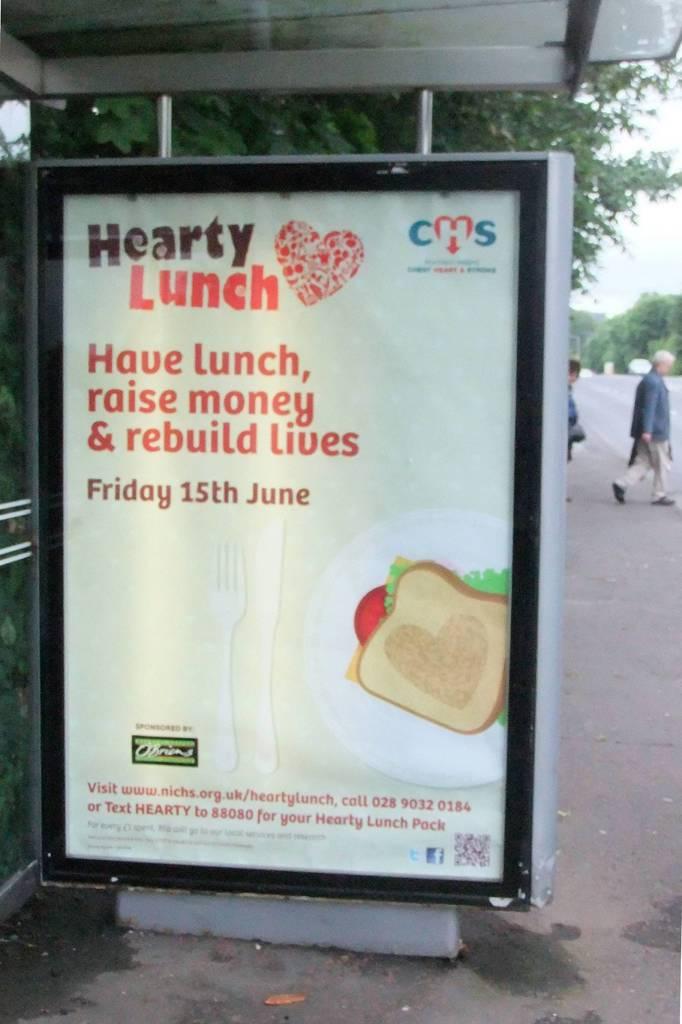Can you donate to hearty lunch?
Make the answer very short. Unanswerable. What day is the event?
Offer a very short reply. Friday 15th june. 